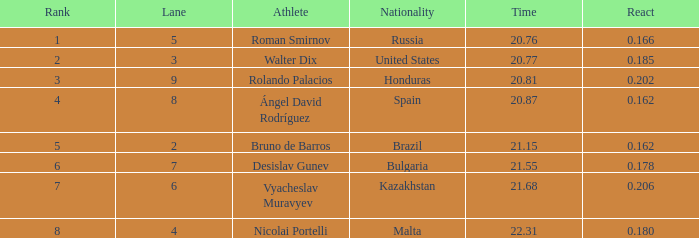What's Brazil's lane with a time less than 21.15? None. 